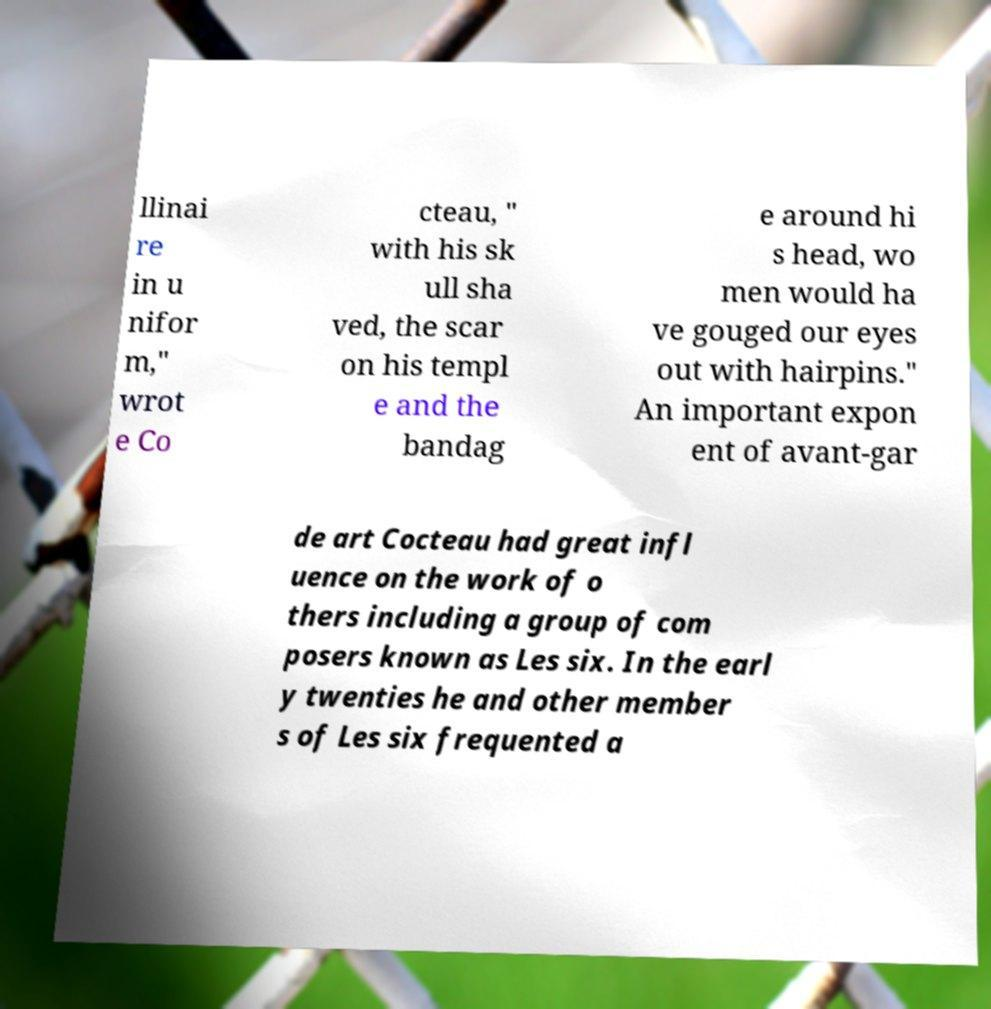For documentation purposes, I need the text within this image transcribed. Could you provide that? llinai re in u nifor m," wrot e Co cteau, " with his sk ull sha ved, the scar on his templ e and the bandag e around hi s head, wo men would ha ve gouged our eyes out with hairpins." An important expon ent of avant-gar de art Cocteau had great infl uence on the work of o thers including a group of com posers known as Les six. In the earl y twenties he and other member s of Les six frequented a 